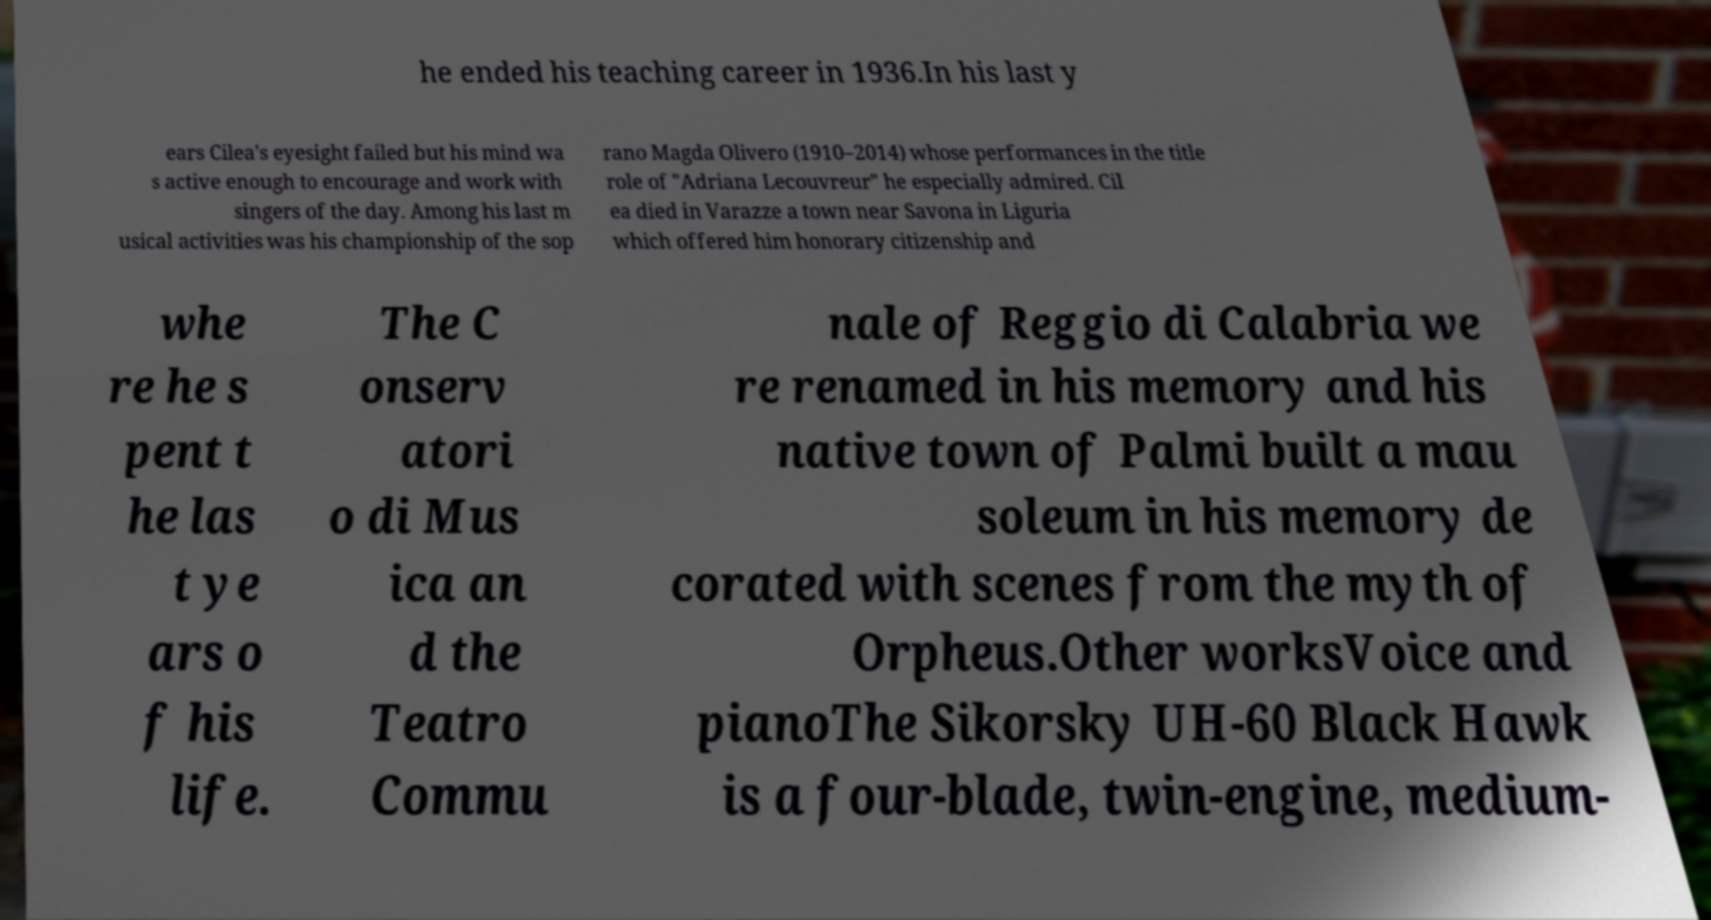What messages or text are displayed in this image? I need them in a readable, typed format. he ended his teaching career in 1936.In his last y ears Cilea's eyesight failed but his mind wa s active enough to encourage and work with singers of the day. Among his last m usical activities was his championship of the sop rano Magda Olivero (1910–2014) whose performances in the title role of "Adriana Lecouvreur" he especially admired. Cil ea died in Varazze a town near Savona in Liguria which offered him honorary citizenship and whe re he s pent t he las t ye ars o f his life. The C onserv atori o di Mus ica an d the Teatro Commu nale of Reggio di Calabria we re renamed in his memory and his native town of Palmi built a mau soleum in his memory de corated with scenes from the myth of Orpheus.Other worksVoice and pianoThe Sikorsky UH-60 Black Hawk is a four-blade, twin-engine, medium- 